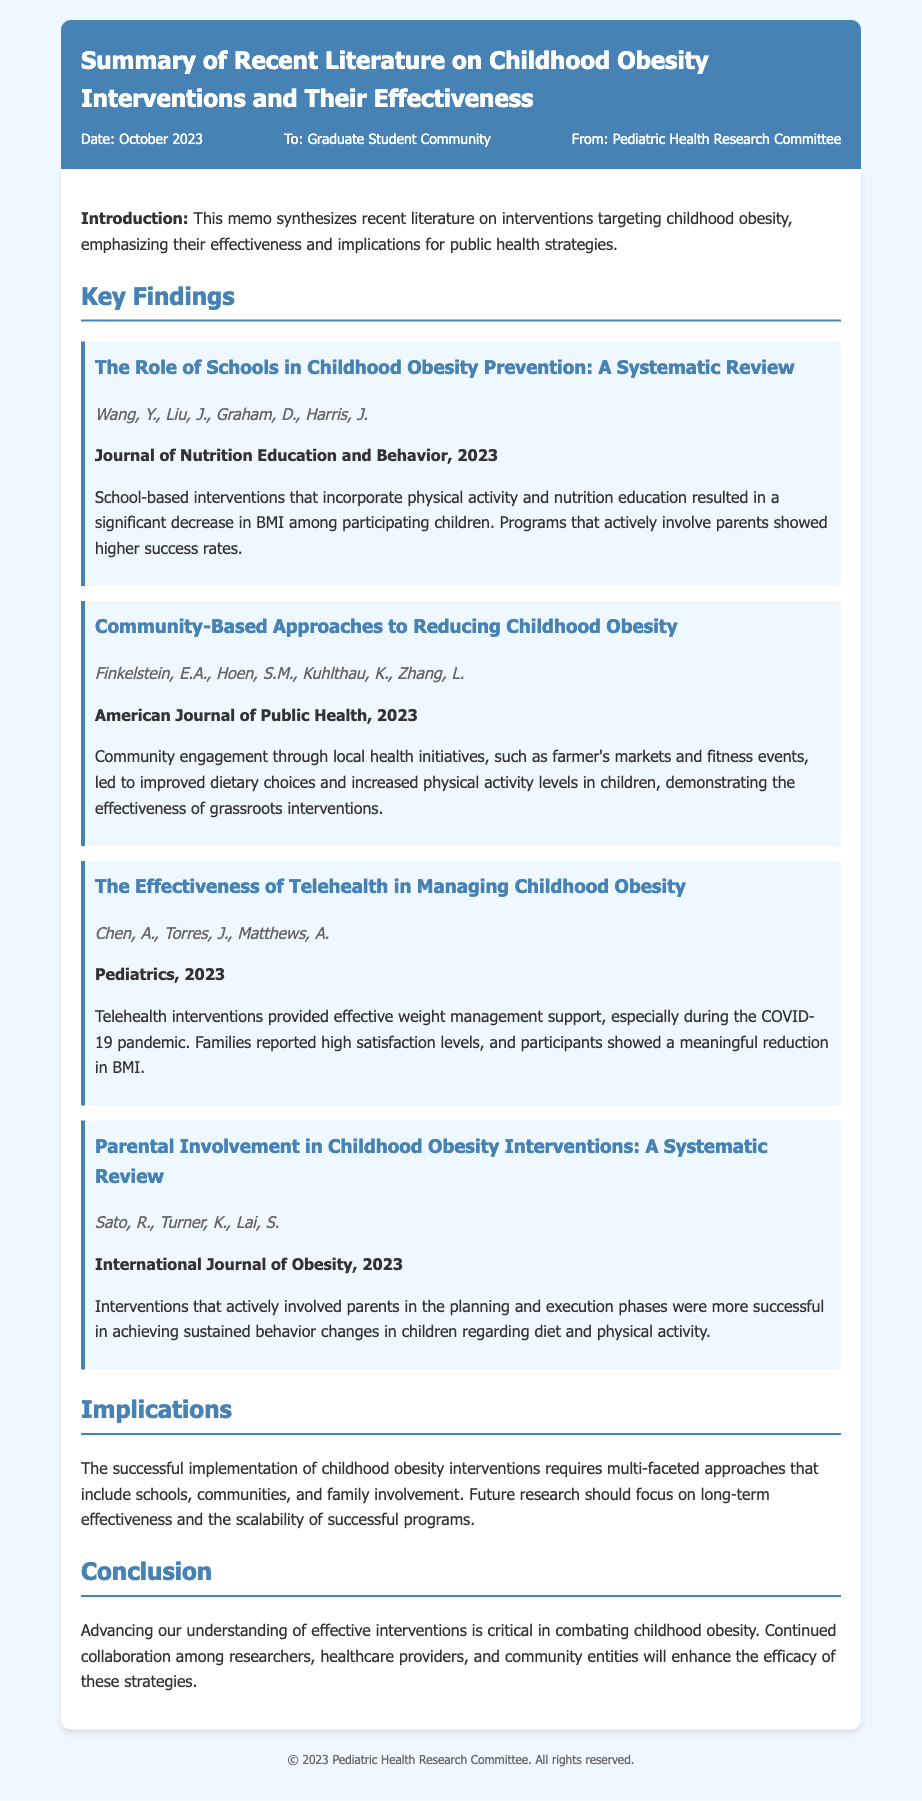What is the title of the memo? The title of the memo is the first prominent text seen in the header portion of the document.
Answer: Summary of Recent Literature on Childhood Obesity Interventions and Their Effectiveness Who are the authors of the study on school-based interventions? The authors are listed under the corresponding study section, providing clear attribution to the researchers involved.
Answer: Wang, Y., Liu, J., Graham, D., Harris, J In which journal was the community-based approaches study published? The publication information is clearly stated below the authors in each study section, denoting where the research was shared.
Answer: American Journal of Public Health What is the primary focus of the telehealth interventions study? This information can be inferred from the brief descriptions provided after each study title and its authors.
Answer: Weight management support What year was the parental involvement study published? The publication year is included in bold text after each study's author names, indicating when the research was released.
Answer: 2023 Which intervention showed improved dietary choices and increased physical activity? This is identified in the description of the study that discusses community-based health initiatives.
Answer: Community engagement through local health initiatives What is stated as necessary for the successful implementation of childhood obesity interventions? The implications section outlines essential factors for successful interventions addressing obesity in children.
Answer: Multi-faceted approaches What type of research should future studies focus on, according to the memo? The conclusion provides guidance on areas for further exploration and research needs related to the topic.
Answer: Long-term effectiveness and scalability of successful programs 